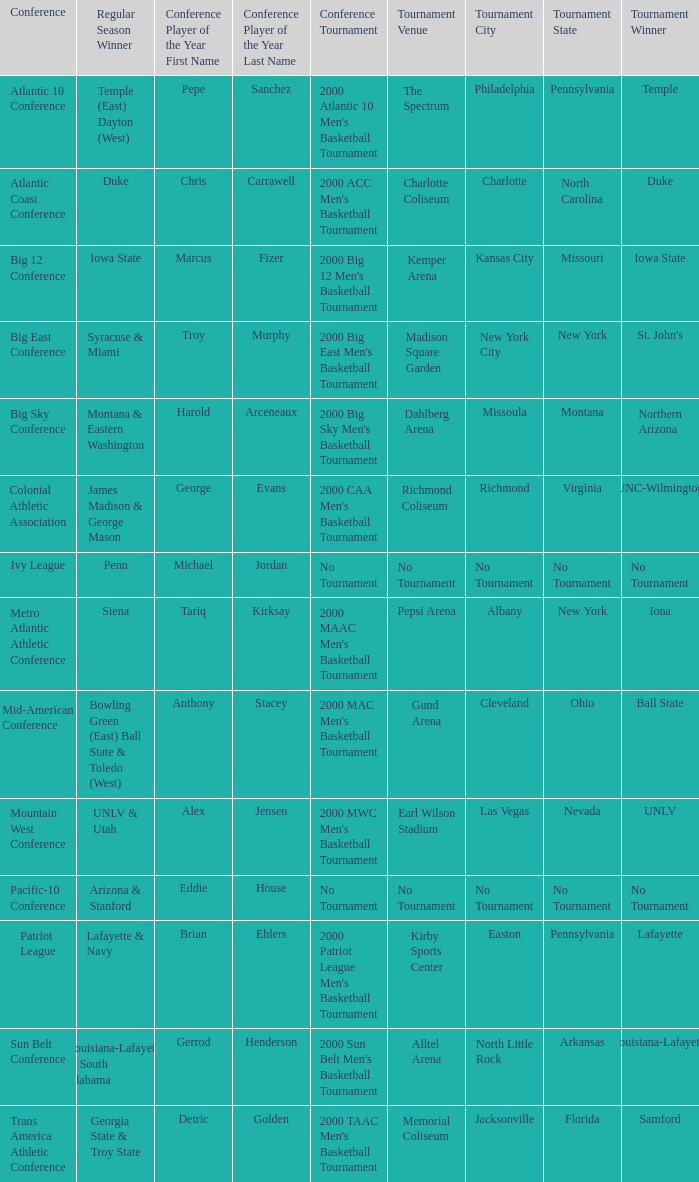Who secured the regular season victory in the ivy league conference? Penn. 